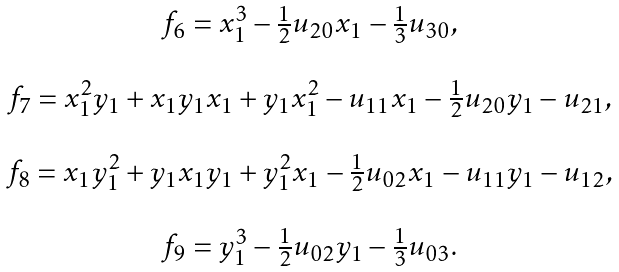Convert formula to latex. <formula><loc_0><loc_0><loc_500><loc_500>\begin{array} { c } f _ { 6 } = x _ { 1 } ^ { 3 } - \frac { 1 } { 2 } u _ { 2 0 } x _ { 1 } - \frac { 1 } { 3 } u _ { 3 0 } , \\ \\ f _ { 7 } = x _ { 1 } ^ { 2 } y _ { 1 } + x _ { 1 } y _ { 1 } x _ { 1 } + y _ { 1 } x _ { 1 } ^ { 2 } - u _ { 1 1 } x _ { 1 } - \frac { 1 } { 2 } u _ { 2 0 } y _ { 1 } - u _ { 2 1 } , \\ \\ f _ { 8 } = x _ { 1 } y _ { 1 } ^ { 2 } + y _ { 1 } x _ { 1 } y _ { 1 } + y _ { 1 } ^ { 2 } x _ { 1 } - \frac { 1 } { 2 } u _ { 0 2 } x _ { 1 } - u _ { 1 1 } y _ { 1 } - u _ { 1 2 } , \\ \\ f _ { 9 } = y _ { 1 } ^ { 3 } - \frac { 1 } { 2 } u _ { 0 2 } y _ { 1 } - \frac { 1 } { 3 } u _ { 0 3 } . \\ \end{array}</formula> 